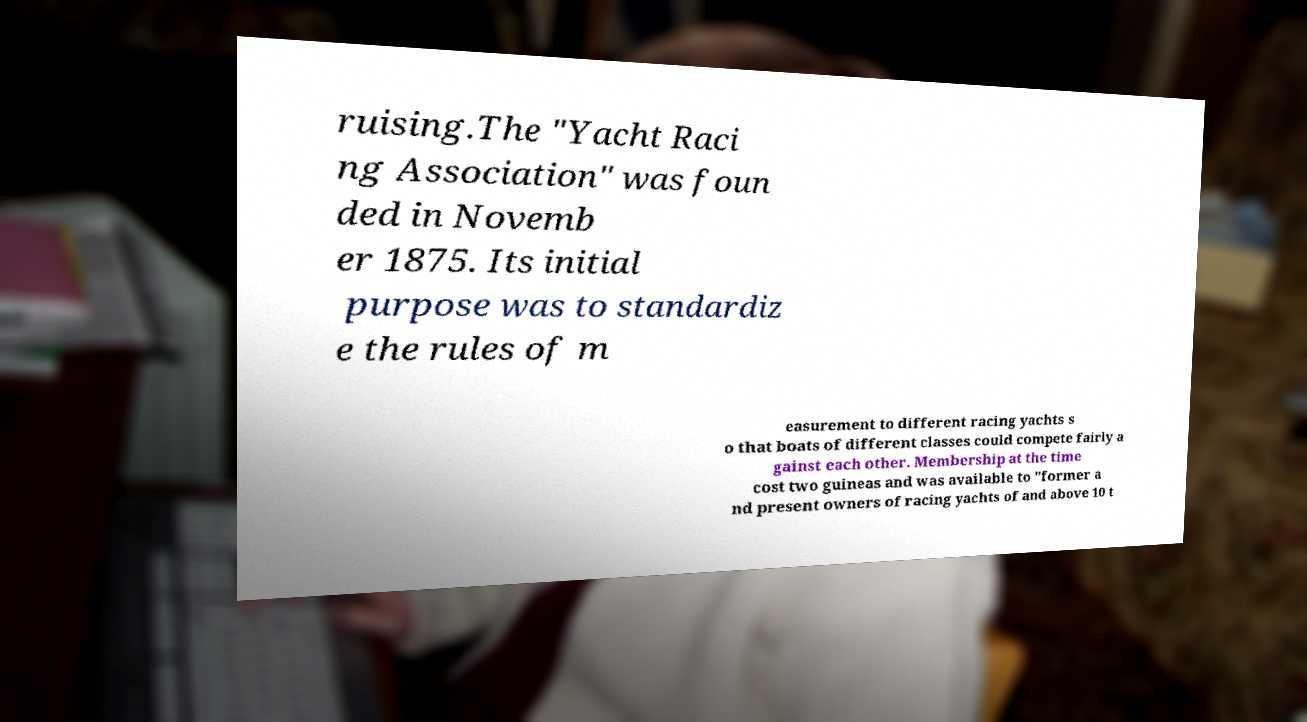There's text embedded in this image that I need extracted. Can you transcribe it verbatim? ruising.The "Yacht Raci ng Association" was foun ded in Novemb er 1875. Its initial purpose was to standardiz e the rules of m easurement to different racing yachts s o that boats of different classes could compete fairly a gainst each other. Membership at the time cost two guineas and was available to "former a nd present owners of racing yachts of and above 10 t 